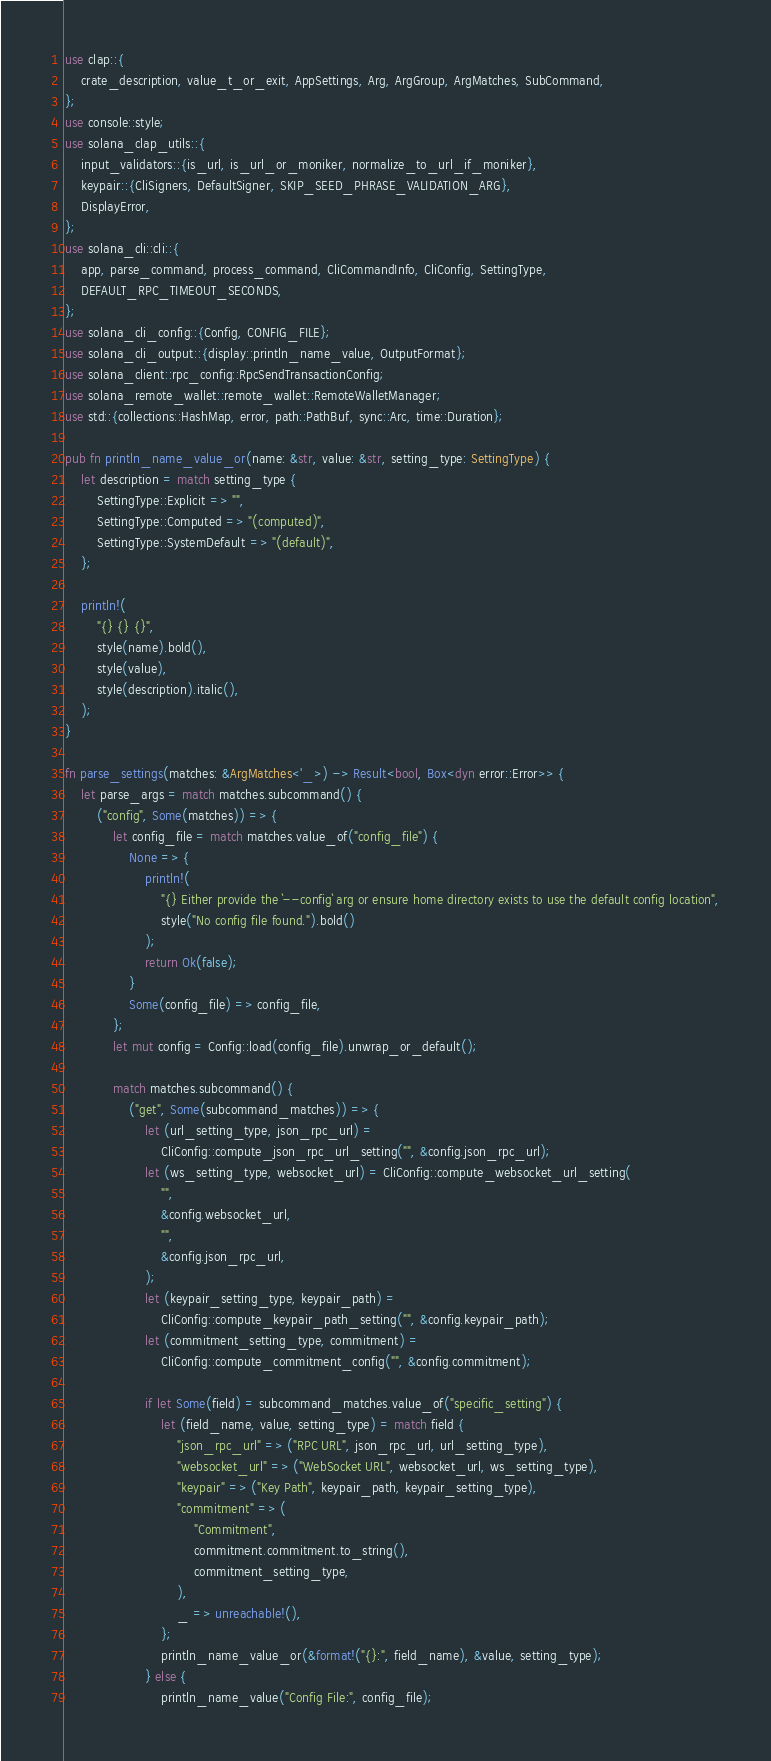Convert code to text. <code><loc_0><loc_0><loc_500><loc_500><_Rust_>use clap::{
    crate_description, value_t_or_exit, AppSettings, Arg, ArgGroup, ArgMatches, SubCommand,
};
use console::style;
use solana_clap_utils::{
    input_validators::{is_url, is_url_or_moniker, normalize_to_url_if_moniker},
    keypair::{CliSigners, DefaultSigner, SKIP_SEED_PHRASE_VALIDATION_ARG},
    DisplayError,
};
use solana_cli::cli::{
    app, parse_command, process_command, CliCommandInfo, CliConfig, SettingType,
    DEFAULT_RPC_TIMEOUT_SECONDS,
};
use solana_cli_config::{Config, CONFIG_FILE};
use solana_cli_output::{display::println_name_value, OutputFormat};
use solana_client::rpc_config::RpcSendTransactionConfig;
use solana_remote_wallet::remote_wallet::RemoteWalletManager;
use std::{collections::HashMap, error, path::PathBuf, sync::Arc, time::Duration};

pub fn println_name_value_or(name: &str, value: &str, setting_type: SettingType) {
    let description = match setting_type {
        SettingType::Explicit => "",
        SettingType::Computed => "(computed)",
        SettingType::SystemDefault => "(default)",
    };

    println!(
        "{} {} {}",
        style(name).bold(),
        style(value),
        style(description).italic(),
    );
}

fn parse_settings(matches: &ArgMatches<'_>) -> Result<bool, Box<dyn error::Error>> {
    let parse_args = match matches.subcommand() {
        ("config", Some(matches)) => {
            let config_file = match matches.value_of("config_file") {
                None => {
                    println!(
                        "{} Either provide the `--config` arg or ensure home directory exists to use the default config location",
                        style("No config file found.").bold()
                    );
                    return Ok(false);
                }
                Some(config_file) => config_file,
            };
            let mut config = Config::load(config_file).unwrap_or_default();

            match matches.subcommand() {
                ("get", Some(subcommand_matches)) => {
                    let (url_setting_type, json_rpc_url) =
                        CliConfig::compute_json_rpc_url_setting("", &config.json_rpc_url);
                    let (ws_setting_type, websocket_url) = CliConfig::compute_websocket_url_setting(
                        "",
                        &config.websocket_url,
                        "",
                        &config.json_rpc_url,
                    );
                    let (keypair_setting_type, keypair_path) =
                        CliConfig::compute_keypair_path_setting("", &config.keypair_path);
                    let (commitment_setting_type, commitment) =
                        CliConfig::compute_commitment_config("", &config.commitment);

                    if let Some(field) = subcommand_matches.value_of("specific_setting") {
                        let (field_name, value, setting_type) = match field {
                            "json_rpc_url" => ("RPC URL", json_rpc_url, url_setting_type),
                            "websocket_url" => ("WebSocket URL", websocket_url, ws_setting_type),
                            "keypair" => ("Key Path", keypair_path, keypair_setting_type),
                            "commitment" => (
                                "Commitment",
                                commitment.commitment.to_string(),
                                commitment_setting_type,
                            ),
                            _ => unreachable!(),
                        };
                        println_name_value_or(&format!("{}:", field_name), &value, setting_type);
                    } else {
                        println_name_value("Config File:", config_file);</code> 